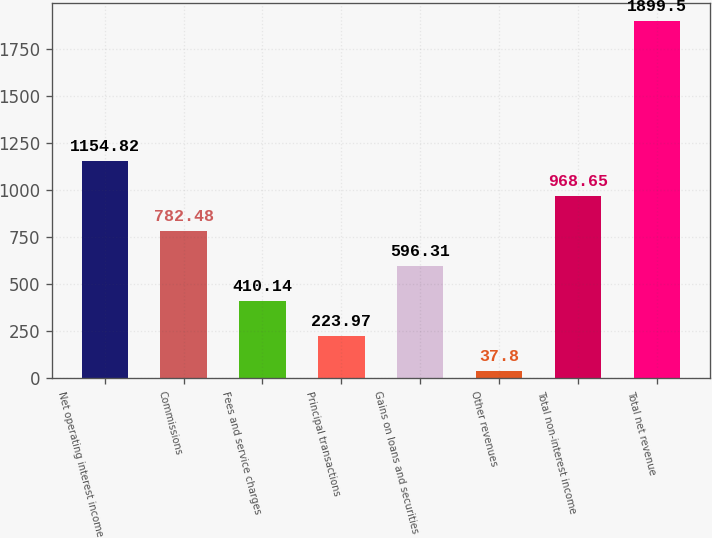Convert chart. <chart><loc_0><loc_0><loc_500><loc_500><bar_chart><fcel>Net operating interest income<fcel>Commissions<fcel>Fees and service charges<fcel>Principal transactions<fcel>Gains on loans and securities<fcel>Other revenues<fcel>Total non-interest income<fcel>Total net revenue<nl><fcel>1154.82<fcel>782.48<fcel>410.14<fcel>223.97<fcel>596.31<fcel>37.8<fcel>968.65<fcel>1899.5<nl></chart> 